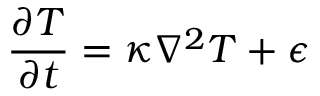Convert formula to latex. <formula><loc_0><loc_0><loc_500><loc_500>{ \frac { \partial T } { \partial t } } = \kappa \nabla ^ { 2 } T + \epsilon</formula> 